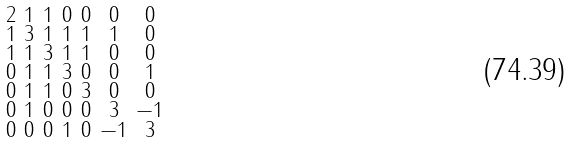<formula> <loc_0><loc_0><loc_500><loc_500>\begin{smallmatrix} 2 & 1 & 1 & 0 & 0 & 0 & 0 \\ 1 & 3 & 1 & 1 & 1 & 1 & 0 \\ 1 & 1 & 3 & 1 & 1 & 0 & 0 \\ 0 & 1 & 1 & 3 & 0 & 0 & 1 \\ 0 & 1 & 1 & 0 & 3 & 0 & 0 \\ 0 & 1 & 0 & 0 & 0 & 3 & - 1 \\ 0 & 0 & 0 & 1 & 0 & - 1 & 3 \end{smallmatrix}</formula> 